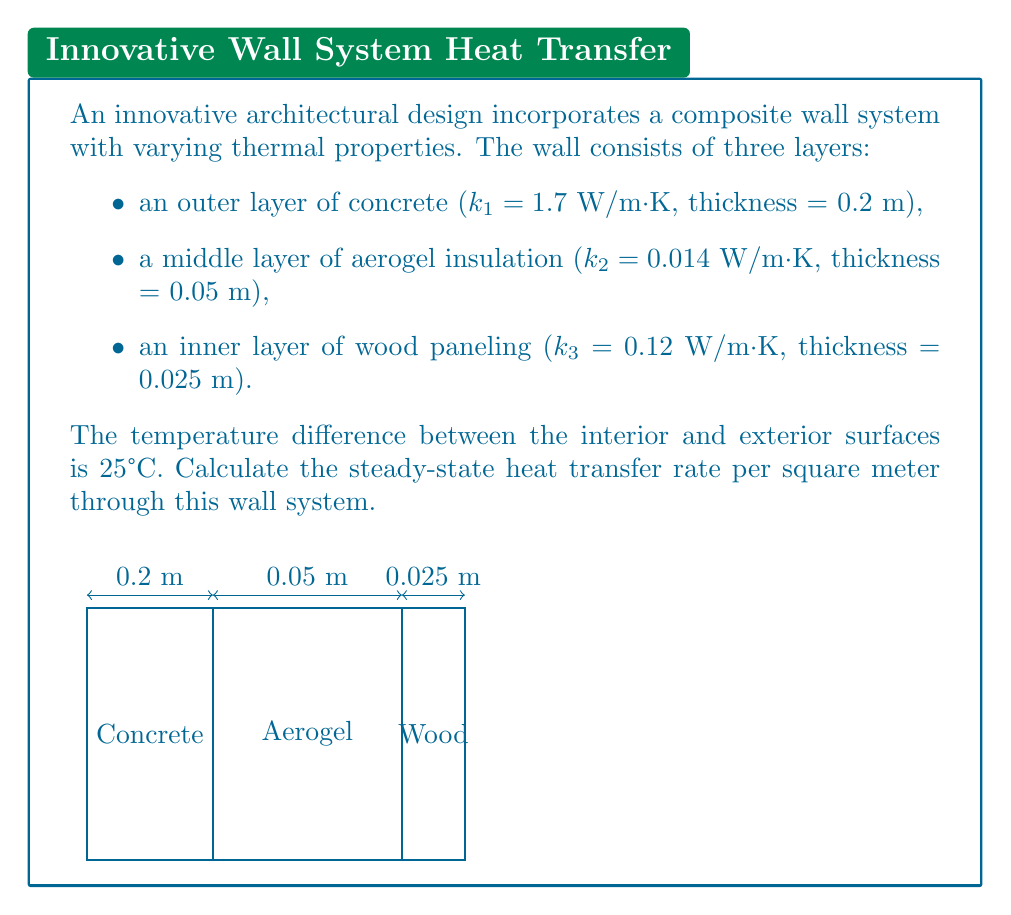Could you help me with this problem? To solve this problem, we'll use the concept of thermal resistance in series and Fourier's law of heat conduction. Let's follow these steps:

1) First, calculate the thermal resistance (R) for each layer:
   $R = \frac{L}{k A}$, where L is thickness, k is thermal conductivity, and A is area (1 m² in this case)

   Concrete: $R_1 = \frac{0.2}{1.7 \times 1} = 0.1176$ m²·K/W
   Aerogel: $R_2 = \frac{0.05}{0.014 \times 1} = 3.5714$ m²·K/W
   Wood: $R_3 = \frac{0.025}{0.12 \times 1} = 0.2083$ m²·K/W

2) Calculate the total thermal resistance:
   $R_{total} = R_1 + R_2 + R_3 = 0.1176 + 3.5714 + 0.2083 = 3.8973$ m²·K/W

3) Use Fourier's law to calculate the heat transfer rate:
   $q = \frac{\Delta T}{R_{total}}$

   Where $\Delta T$ is the temperature difference (25°C or 25 K)

   $q = \frac{25}{3.8973} = 6.4147$ W/m²

Therefore, the steady-state heat transfer rate through this wall system is approximately 6.41 W/m².
Answer: 6.41 W/m² 